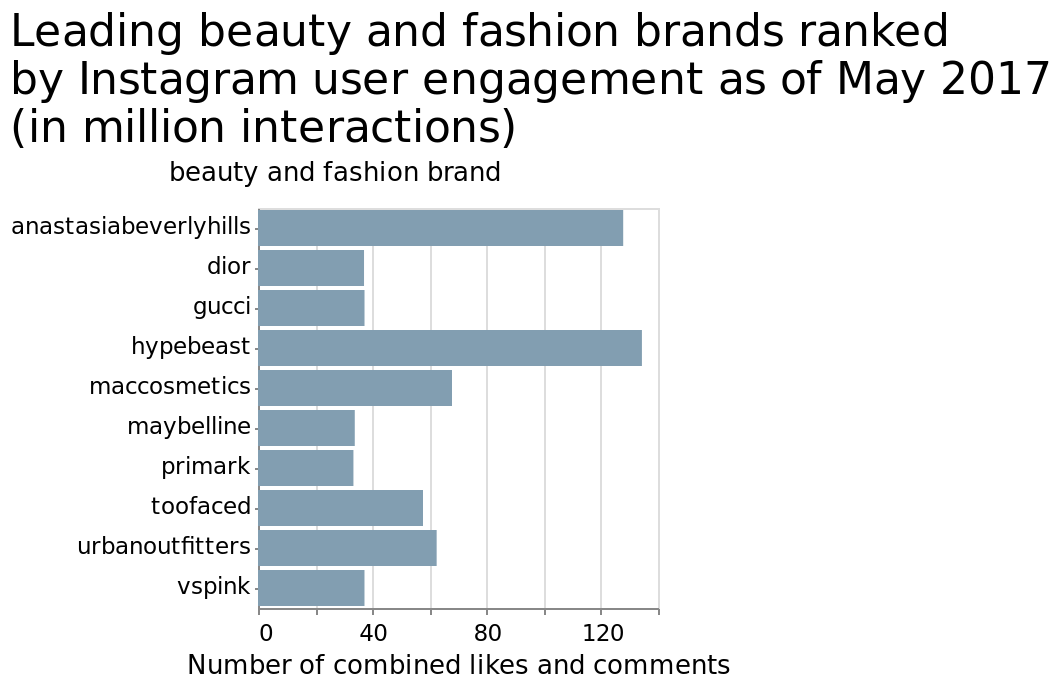<image>
Which two brands have the least number of interactions?  Maybelene and primakr have the least number of interactions, around 30M. What is the title of the bar chart and what does it measure?  The title of the bar chart is "Leading beauty and fashion brands ranked by Instagram user engagement as of May 2017 (in million interactions)". It measures the number of combined likes and comments. Offer a thorough analysis of the image. Hypebeast has the most likes and comments of these brands.  Maybelline and primark jointly have the lowest number of likes and comments. How many interactions does Hypebeast have? The number of interactions for Hypebeast is not specified in the given description. Do Maybelene and primakr have the most number of interactions, around 30M? No. Maybelene and primakr have the least number of interactions, around 30M. 